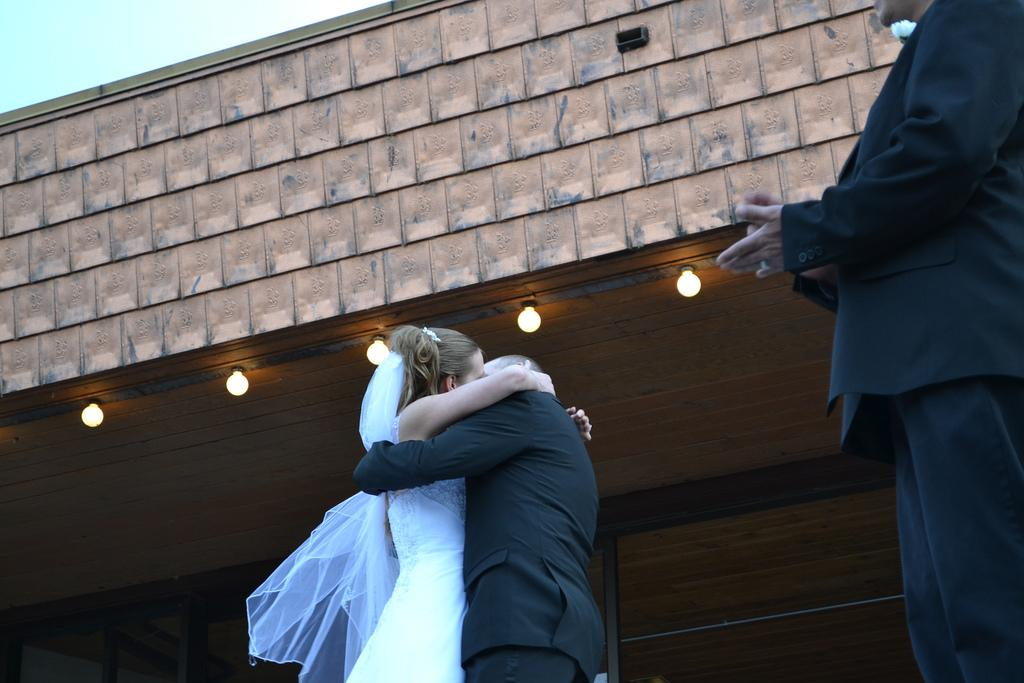How many persons are in the image? There are persons in the image. What can be seen in the background of the image? In the background of the image, there is a wall, lights, a wooden frame, the sky, and other unspecified objects. Can you describe the lighting in the image? The lights in the background of the image provide illumination. What is the color of the sky in the image? The sky is visible in the background of the image, but the color is not specified. What type of needle is being used by the person in the image? There is no needle present in the image. Can you describe the self-awareness of the person in the image? The image does not provide information about the person's self-awareness. 